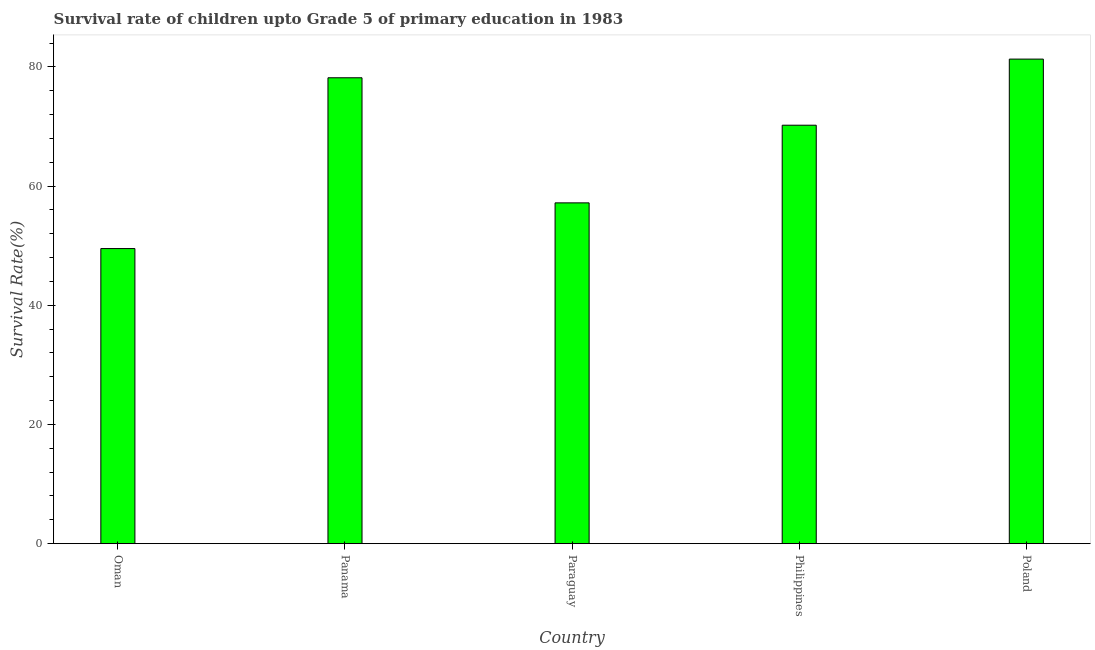Does the graph contain any zero values?
Your response must be concise. No. Does the graph contain grids?
Ensure brevity in your answer.  No. What is the title of the graph?
Ensure brevity in your answer.  Survival rate of children upto Grade 5 of primary education in 1983 . What is the label or title of the X-axis?
Your answer should be very brief. Country. What is the label or title of the Y-axis?
Your answer should be very brief. Survival Rate(%). What is the survival rate in Philippines?
Ensure brevity in your answer.  70.22. Across all countries, what is the maximum survival rate?
Provide a succinct answer. 81.31. Across all countries, what is the minimum survival rate?
Ensure brevity in your answer.  49.52. In which country was the survival rate maximum?
Keep it short and to the point. Poland. In which country was the survival rate minimum?
Your response must be concise. Oman. What is the sum of the survival rate?
Offer a very short reply. 336.41. What is the difference between the survival rate in Panama and Philippines?
Provide a short and direct response. 7.96. What is the average survival rate per country?
Make the answer very short. 67.28. What is the median survival rate?
Your answer should be compact. 70.22. In how many countries, is the survival rate greater than 12 %?
Make the answer very short. 5. What is the ratio of the survival rate in Panama to that in Poland?
Give a very brief answer. 0.96. Is the survival rate in Paraguay less than that in Poland?
Your response must be concise. Yes. What is the difference between the highest and the second highest survival rate?
Provide a succinct answer. 3.13. Is the sum of the survival rate in Oman and Paraguay greater than the maximum survival rate across all countries?
Your answer should be very brief. Yes. What is the difference between the highest and the lowest survival rate?
Make the answer very short. 31.79. Are all the bars in the graph horizontal?
Provide a short and direct response. No. What is the difference between two consecutive major ticks on the Y-axis?
Your answer should be very brief. 20. Are the values on the major ticks of Y-axis written in scientific E-notation?
Your answer should be compact. No. What is the Survival Rate(%) of Oman?
Offer a terse response. 49.52. What is the Survival Rate(%) of Panama?
Your answer should be very brief. 78.18. What is the Survival Rate(%) of Paraguay?
Make the answer very short. 57.19. What is the Survival Rate(%) of Philippines?
Provide a succinct answer. 70.22. What is the Survival Rate(%) in Poland?
Give a very brief answer. 81.31. What is the difference between the Survival Rate(%) in Oman and Panama?
Provide a short and direct response. -28.66. What is the difference between the Survival Rate(%) in Oman and Paraguay?
Make the answer very short. -7.67. What is the difference between the Survival Rate(%) in Oman and Philippines?
Your answer should be compact. -20.7. What is the difference between the Survival Rate(%) in Oman and Poland?
Make the answer very short. -31.79. What is the difference between the Survival Rate(%) in Panama and Paraguay?
Offer a terse response. 20.99. What is the difference between the Survival Rate(%) in Panama and Philippines?
Your answer should be compact. 7.96. What is the difference between the Survival Rate(%) in Panama and Poland?
Ensure brevity in your answer.  -3.13. What is the difference between the Survival Rate(%) in Paraguay and Philippines?
Provide a short and direct response. -13.03. What is the difference between the Survival Rate(%) in Paraguay and Poland?
Your answer should be compact. -24.13. What is the difference between the Survival Rate(%) in Philippines and Poland?
Your response must be concise. -11.09. What is the ratio of the Survival Rate(%) in Oman to that in Panama?
Offer a terse response. 0.63. What is the ratio of the Survival Rate(%) in Oman to that in Paraguay?
Make the answer very short. 0.87. What is the ratio of the Survival Rate(%) in Oman to that in Philippines?
Your answer should be very brief. 0.7. What is the ratio of the Survival Rate(%) in Oman to that in Poland?
Provide a succinct answer. 0.61. What is the ratio of the Survival Rate(%) in Panama to that in Paraguay?
Give a very brief answer. 1.37. What is the ratio of the Survival Rate(%) in Panama to that in Philippines?
Your answer should be compact. 1.11. What is the ratio of the Survival Rate(%) in Panama to that in Poland?
Offer a very short reply. 0.96. What is the ratio of the Survival Rate(%) in Paraguay to that in Philippines?
Provide a succinct answer. 0.81. What is the ratio of the Survival Rate(%) in Paraguay to that in Poland?
Give a very brief answer. 0.7. What is the ratio of the Survival Rate(%) in Philippines to that in Poland?
Give a very brief answer. 0.86. 